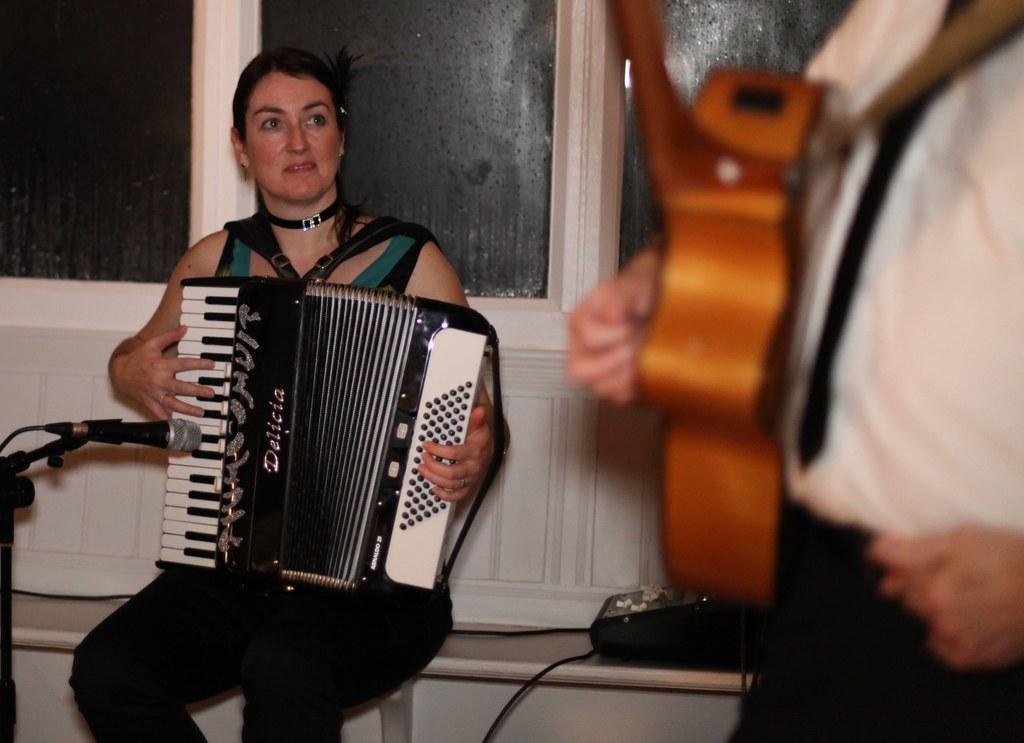Could you give a brief overview of what you see in this image? In this picture I can see a woman playing piano on the left side. I can see a person holding the musical instrument on the right side. I can see the microphone. I can see glass windows. 